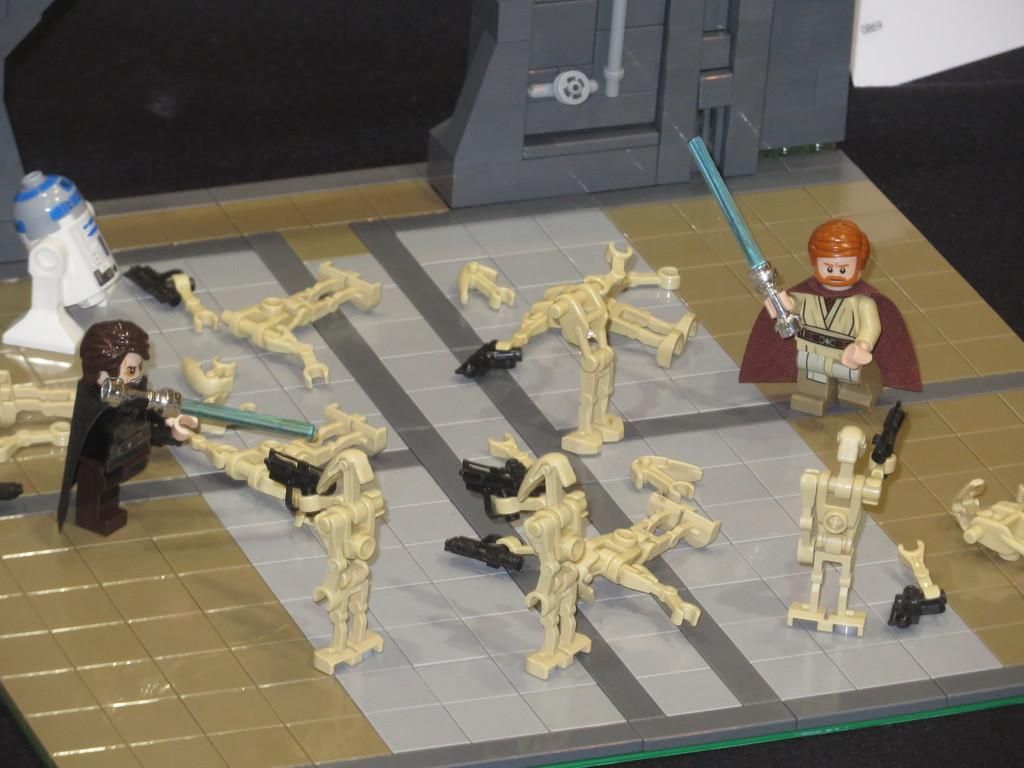What type of objects can be seen in the image? There are many toys in the image. Can you describe the toys in the image? Unfortunately, the facts provided do not give specific details about the toys. Are there any other objects or elements in the image besides the toys? The facts provided do not mention any other objects or elements in the image. How many books are stacked on the machine in the image? There are no books or machines present in the image; it only contains toys. 